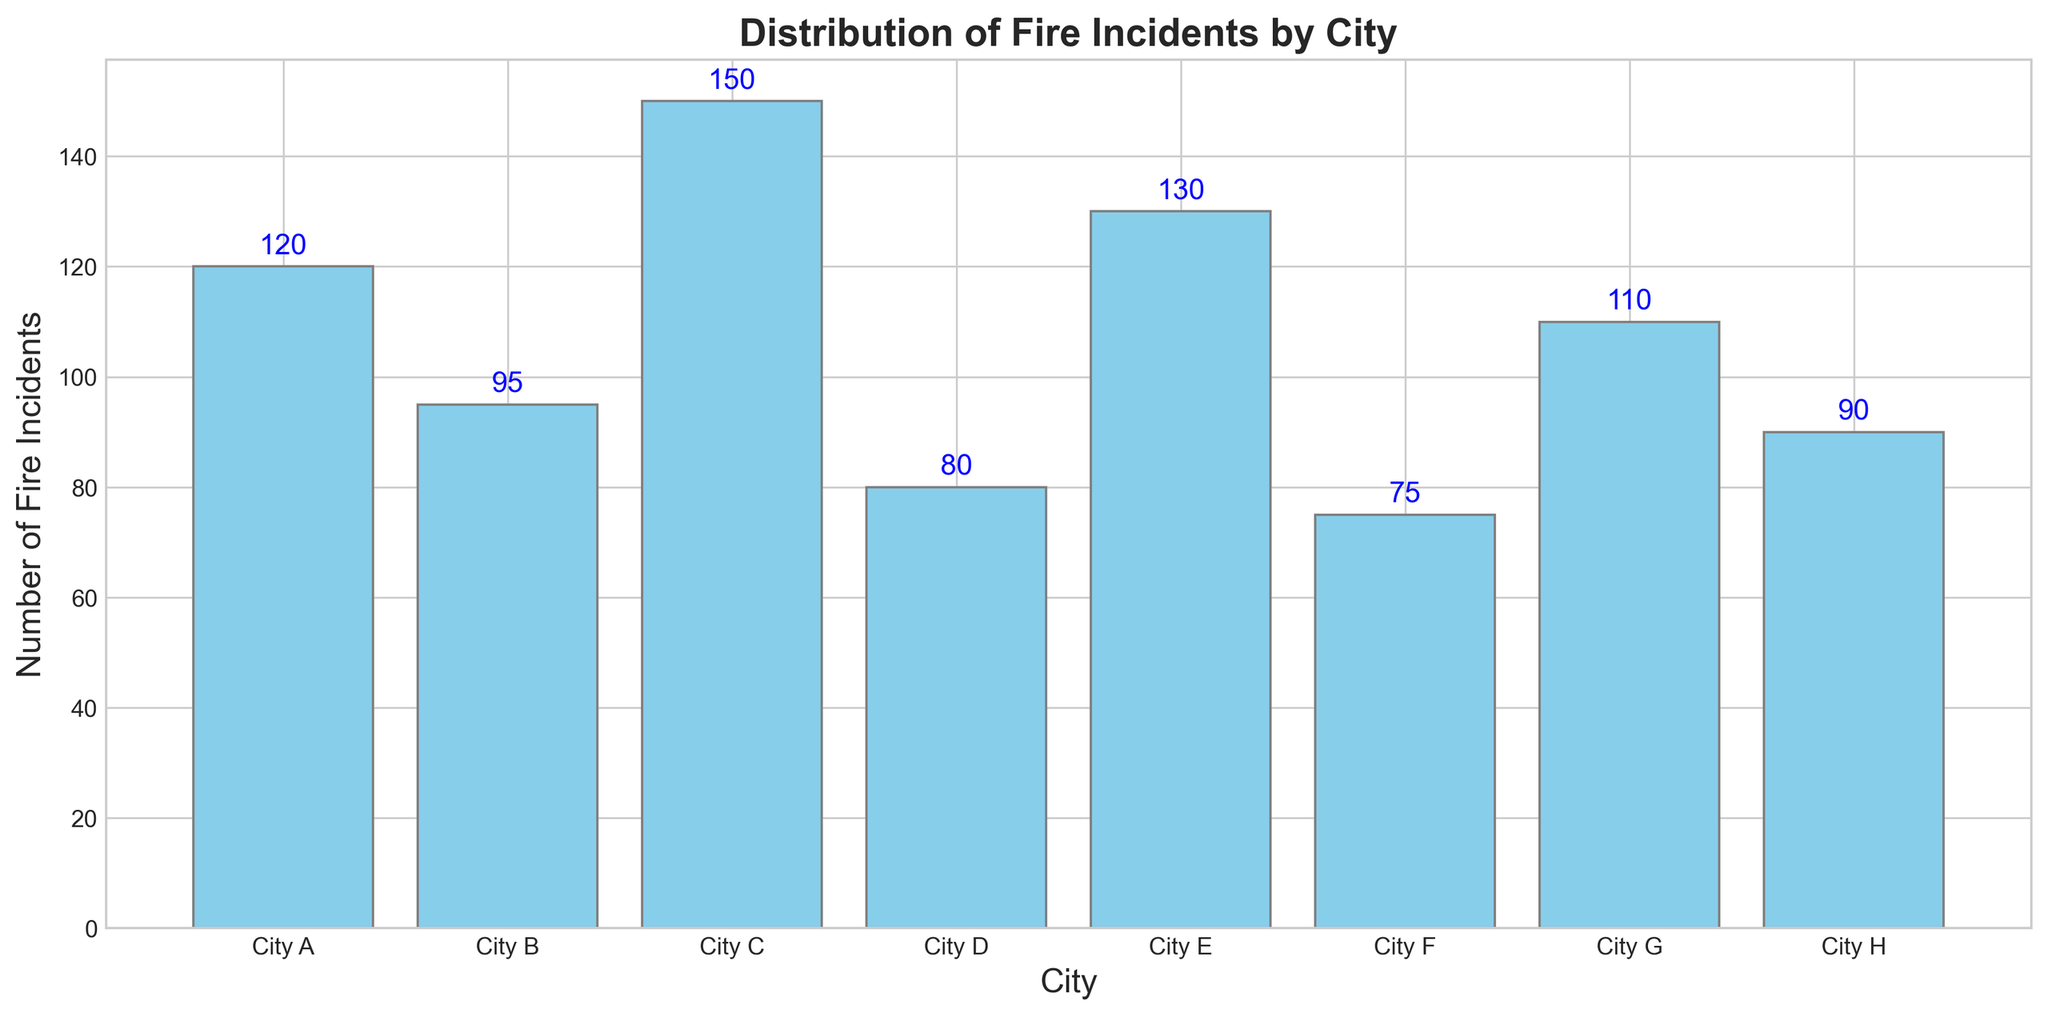Which city has the highest number of fire incidents? City C has the highest bar, indicating it has the most fire incidents.
Answer: City C Which city has the fewest number of fire incidents? City F has the shortest bar, meaning it has the fewest fire incidents.
Answer: City F What is the total number of fire incidents reported in City A and City B? City A has 120 incidents and City B has 95. The total is 120 + 95.
Answer: 215 What is the average number of fire incidents across all cities? The numbers are 120, 95, 150, 80, 130, 75, 110, and 90. The sum is 850, and there are 8 cities. The average is 850 / 8.
Answer: 106.25 Which cities have more than 100 fire incidents? From the heights of the bars: City A (120), City C (150), City E (130), and City G (110) all have more than 100 incidents.
Answer: City A, City C, City E, City G How many more fire incidents does City C have compared to City D? City C has 150 incidents, while City D has 80. The difference is 150 - 80.
Answer: 70 Which city has the closest number of fire incidents to the average of all cities? The average is 106.25. City G has 110, which is the closest to 106.25.
Answer: City G What is the range of fire incidents (difference between the highest and lowest)? Highest is 150 (City C) and lowest is 75 (City F). The range is 150 - 75.
Answer: 75 Arrange the cities in descending order based on the number of fire incidents. The incidents in order: City C (150), City E (130), City A (120), City G (110), City B (95), City H (90), City D (80), and City F (75).
Answer: City C, City E, City A, City G, City B, City H, City D, City F How many cities have fire incidents between 80 and 120 inclusive? The cities are City A (120), City B (95), City D (80), City H (90), and City G (110). There are 5 cities.
Answer: 5 